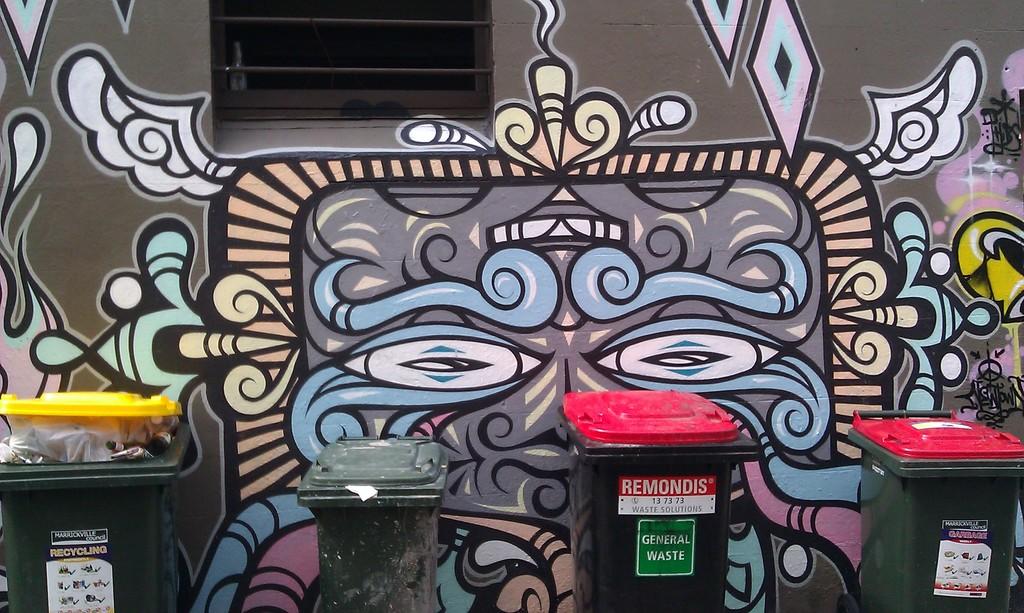What is inside the garbage pails?
Ensure brevity in your answer.  General waste. What word is written with white letters on a red background?
Provide a succinct answer. Remondis. 